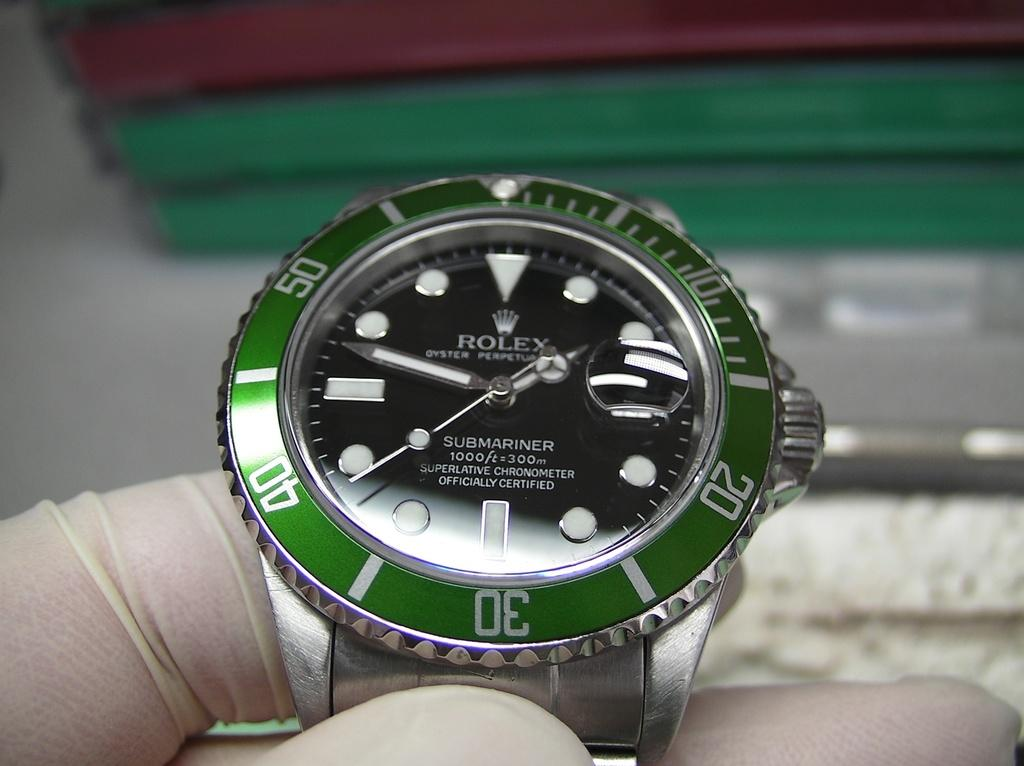<image>
Render a clear and concise summary of the photo. A watch says "ROLEX" on the black face. 